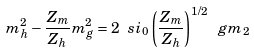Convert formula to latex. <formula><loc_0><loc_0><loc_500><loc_500>m _ { h } ^ { 2 } - \frac { Z _ { m } } { Z _ { h } } m _ { g } ^ { 2 } = 2 \ s i _ { 0 } \left ( \frac { Z _ { m } } { Z _ { h } } \right ) ^ { 1 / 2 } \ g m _ { 2 }</formula> 